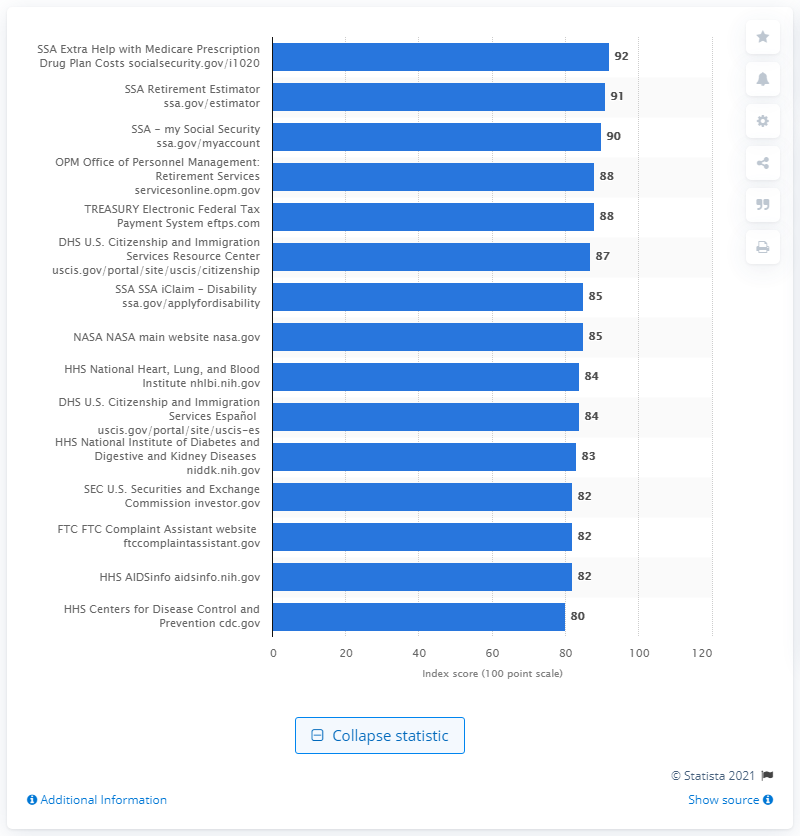Highlight a few significant elements in this photo. The score of the "Extra Help with Medicare Prescription Drug Plan Costs" page is 92. 